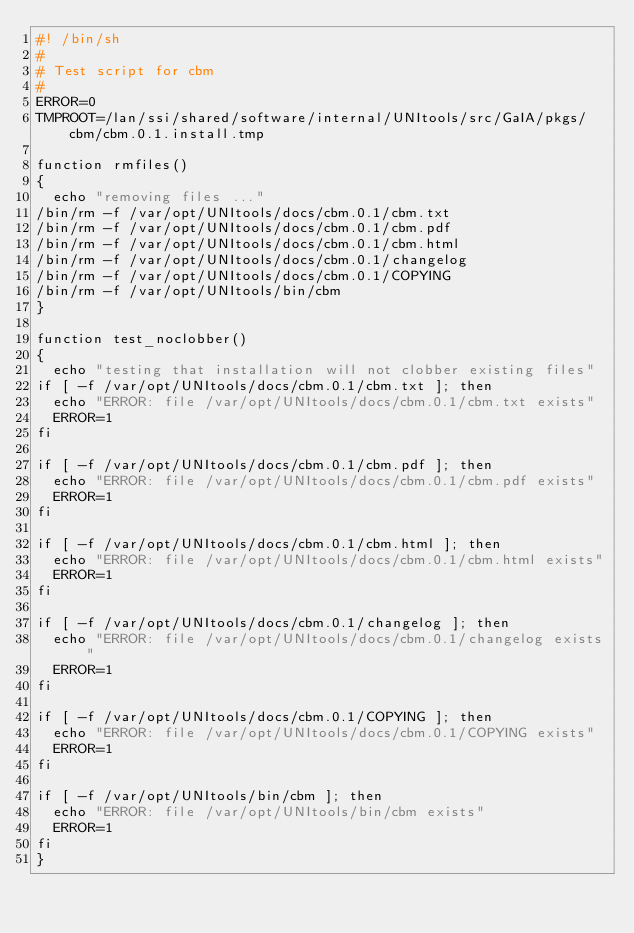<code> <loc_0><loc_0><loc_500><loc_500><_Bash_>#! /bin/sh
#
# Test script for cbm
#
ERROR=0
TMPROOT=/lan/ssi/shared/software/internal/UNItools/src/GaIA/pkgs/cbm/cbm.0.1.install.tmp

function rmfiles()
{
	echo "removing files ..."
/bin/rm -f /var/opt/UNItools/docs/cbm.0.1/cbm.txt
/bin/rm -f /var/opt/UNItools/docs/cbm.0.1/cbm.pdf
/bin/rm -f /var/opt/UNItools/docs/cbm.0.1/cbm.html
/bin/rm -f /var/opt/UNItools/docs/cbm.0.1/changelog
/bin/rm -f /var/opt/UNItools/docs/cbm.0.1/COPYING
/bin/rm -f /var/opt/UNItools/bin/cbm
}

function test_noclobber()
{
	echo "testing that installation will not clobber existing files"
if [ -f /var/opt/UNItools/docs/cbm.0.1/cbm.txt ]; then
	echo "ERROR: file /var/opt/UNItools/docs/cbm.0.1/cbm.txt exists"
	ERROR=1
fi

if [ -f /var/opt/UNItools/docs/cbm.0.1/cbm.pdf ]; then
	echo "ERROR: file /var/opt/UNItools/docs/cbm.0.1/cbm.pdf exists"
	ERROR=1
fi

if [ -f /var/opt/UNItools/docs/cbm.0.1/cbm.html ]; then
	echo "ERROR: file /var/opt/UNItools/docs/cbm.0.1/cbm.html exists"
	ERROR=1
fi

if [ -f /var/opt/UNItools/docs/cbm.0.1/changelog ]; then
	echo "ERROR: file /var/opt/UNItools/docs/cbm.0.1/changelog exists"
	ERROR=1
fi

if [ -f /var/opt/UNItools/docs/cbm.0.1/COPYING ]; then
	echo "ERROR: file /var/opt/UNItools/docs/cbm.0.1/COPYING exists"
	ERROR=1
fi

if [ -f /var/opt/UNItools/bin/cbm ]; then
	echo "ERROR: file /var/opt/UNItools/bin/cbm exists"
	ERROR=1
fi
}
</code> 